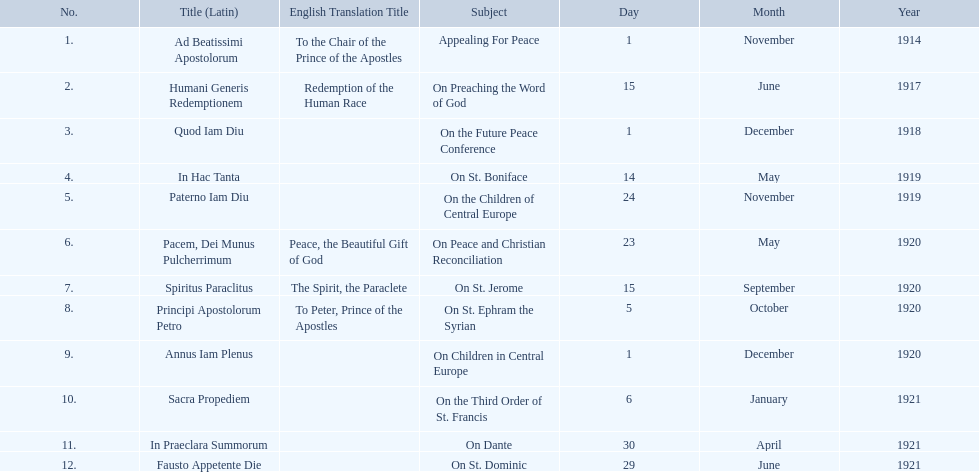What is the dates of the list of encyclicals of pope benedict xv? 1 November 1914, 15 June 1917, 1 December 1918, 14 May 1919, 24 November 1919, 23 May 1920, 15 September 1920, 5 October 1920, 1 December 1920, 6 January 1921, 30 April 1921, 29 June 1921. Of these dates, which subject was on 23 may 1920? On Peace and Christian Reconciliation. 